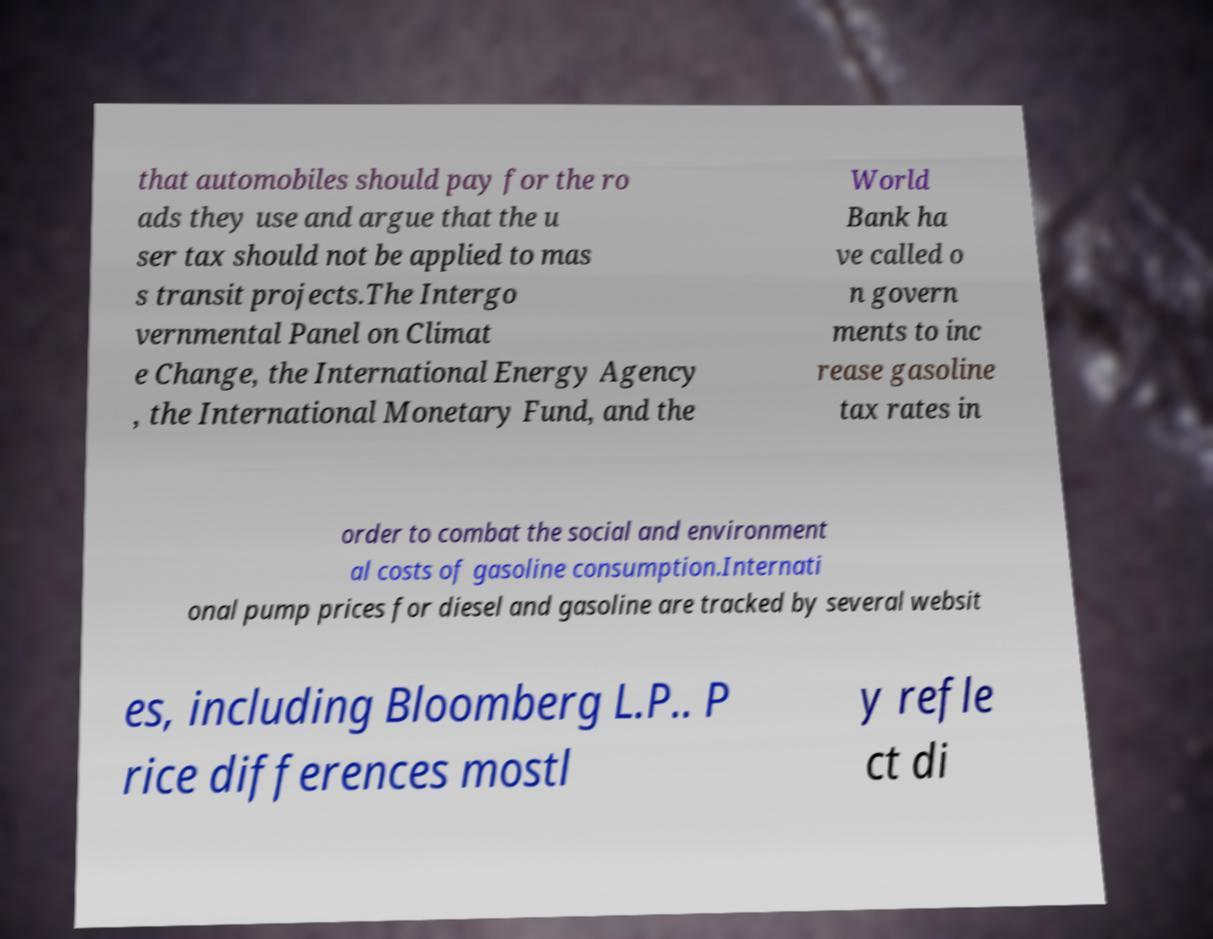For documentation purposes, I need the text within this image transcribed. Could you provide that? that automobiles should pay for the ro ads they use and argue that the u ser tax should not be applied to mas s transit projects.The Intergo vernmental Panel on Climat e Change, the International Energy Agency , the International Monetary Fund, and the World Bank ha ve called o n govern ments to inc rease gasoline tax rates in order to combat the social and environment al costs of gasoline consumption.Internati onal pump prices for diesel and gasoline are tracked by several websit es, including Bloomberg L.P.. P rice differences mostl y refle ct di 